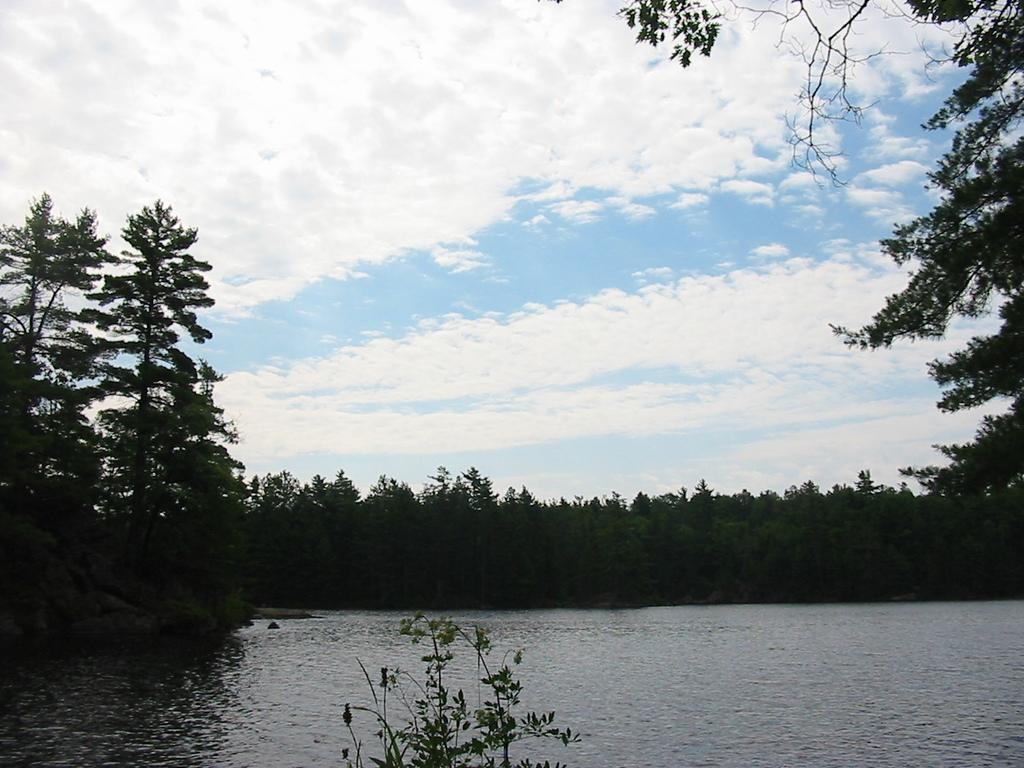Could you give a brief overview of what you see in this image? This is an outside view. At the bottom I can see the water and a plant. In the background there are many trees. At the top of the image, I can see the sky and clouds. 